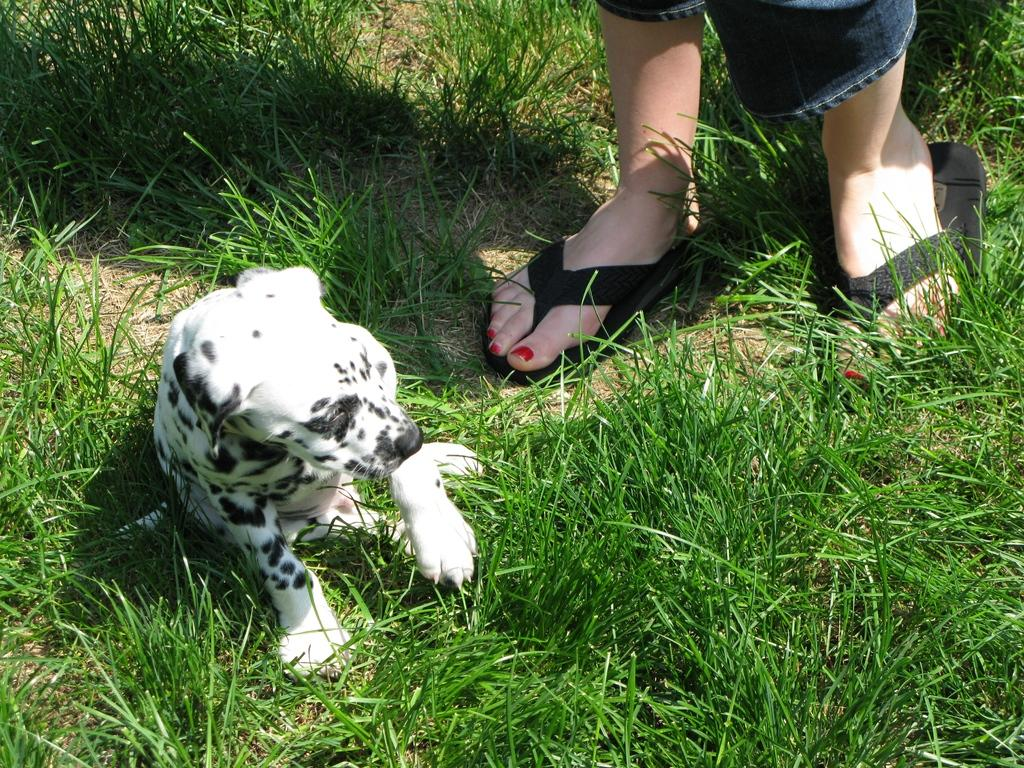What animal is present in the image? There is a dog in the image. Where is the dog located? The dog is sitting on the grass. Is there anyone else in the image besides the dog? Yes, there is a person standing in the image. What question is the boy asking the parent in the image? There is no boy or parent present in the image, so it is not possible to answer that question. 